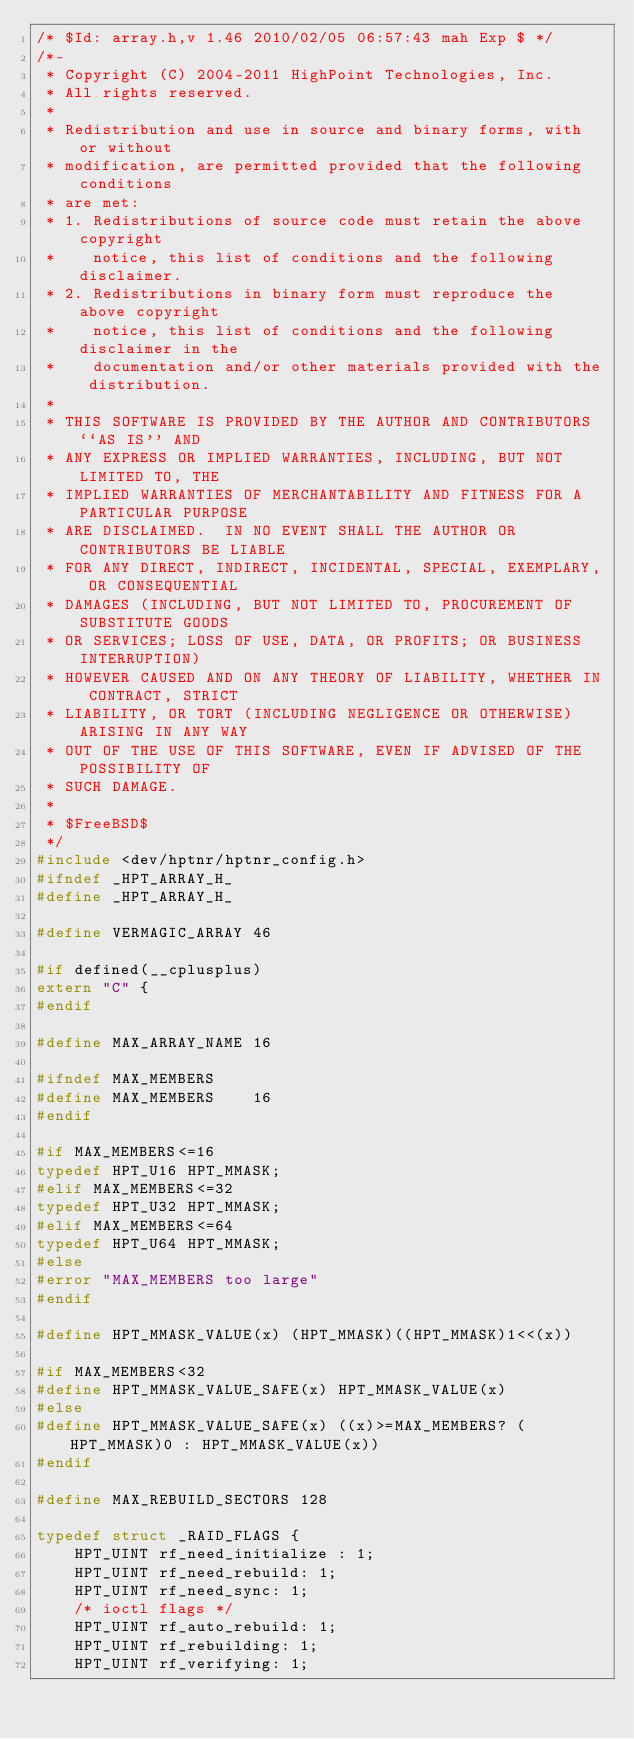Convert code to text. <code><loc_0><loc_0><loc_500><loc_500><_C_>/* $Id: array.h,v 1.46 2010/02/05 06:57:43 mah Exp $ */
/*-
 * Copyright (C) 2004-2011 HighPoint Technologies, Inc.
 * All rights reserved.
 *
 * Redistribution and use in source and binary forms, with or without
 * modification, are permitted provided that the following conditions
 * are met:
 * 1. Redistributions of source code must retain the above copyright
 *    notice, this list of conditions and the following disclaimer.
 * 2. Redistributions in binary form must reproduce the above copyright
 *    notice, this list of conditions and the following disclaimer in the
 *    documentation and/or other materials provided with the distribution.
 *
 * THIS SOFTWARE IS PROVIDED BY THE AUTHOR AND CONTRIBUTORS ``AS IS'' AND
 * ANY EXPRESS OR IMPLIED WARRANTIES, INCLUDING, BUT NOT LIMITED TO, THE
 * IMPLIED WARRANTIES OF MERCHANTABILITY AND FITNESS FOR A PARTICULAR PURPOSE
 * ARE DISCLAIMED.  IN NO EVENT SHALL THE AUTHOR OR CONTRIBUTORS BE LIABLE
 * FOR ANY DIRECT, INDIRECT, INCIDENTAL, SPECIAL, EXEMPLARY, OR CONSEQUENTIAL
 * DAMAGES (INCLUDING, BUT NOT LIMITED TO, PROCUREMENT OF SUBSTITUTE GOODS
 * OR SERVICES; LOSS OF USE, DATA, OR PROFITS; OR BUSINESS INTERRUPTION)
 * HOWEVER CAUSED AND ON ANY THEORY OF LIABILITY, WHETHER IN CONTRACT, STRICT
 * LIABILITY, OR TORT (INCLUDING NEGLIGENCE OR OTHERWISE) ARISING IN ANY WAY
 * OUT OF THE USE OF THIS SOFTWARE, EVEN IF ADVISED OF THE POSSIBILITY OF
 * SUCH DAMAGE.
 * 
 * $FreeBSD$
 */
#include <dev/hptnr/hptnr_config.h>
#ifndef _HPT_ARRAY_H_
#define _HPT_ARRAY_H_

#define VERMAGIC_ARRAY 46

#if defined(__cplusplus)
extern "C" {
#endif

#define MAX_ARRAY_NAME 16

#ifndef MAX_MEMBERS
#define MAX_MEMBERS    16
#endif

#if MAX_MEMBERS<=16
typedef HPT_U16 HPT_MMASK;
#elif MAX_MEMBERS<=32
typedef HPT_U32 HPT_MMASK;
#elif MAX_MEMBERS<=64
typedef HPT_U64 HPT_MMASK;
#else 
#error "MAX_MEMBERS too large"
#endif

#define HPT_MMASK_VALUE(x) (HPT_MMASK)((HPT_MMASK)1<<(x))

#if MAX_MEMBERS<32
#define HPT_MMASK_VALUE_SAFE(x) HPT_MMASK_VALUE(x)
#else 
#define HPT_MMASK_VALUE_SAFE(x) ((x)>=MAX_MEMBERS? (HPT_MMASK)0 : HPT_MMASK_VALUE(x))
#endif

#define MAX_REBUILD_SECTORS 128

typedef struct _RAID_FLAGS {
	HPT_UINT rf_need_initialize : 1;    
	HPT_UINT rf_need_rebuild: 1;        
	HPT_UINT rf_need_sync: 1;           
	/* ioctl flags */
	HPT_UINT rf_auto_rebuild: 1;
	HPT_UINT rf_rebuilding: 1;          
	HPT_UINT rf_verifying: 1;</code> 